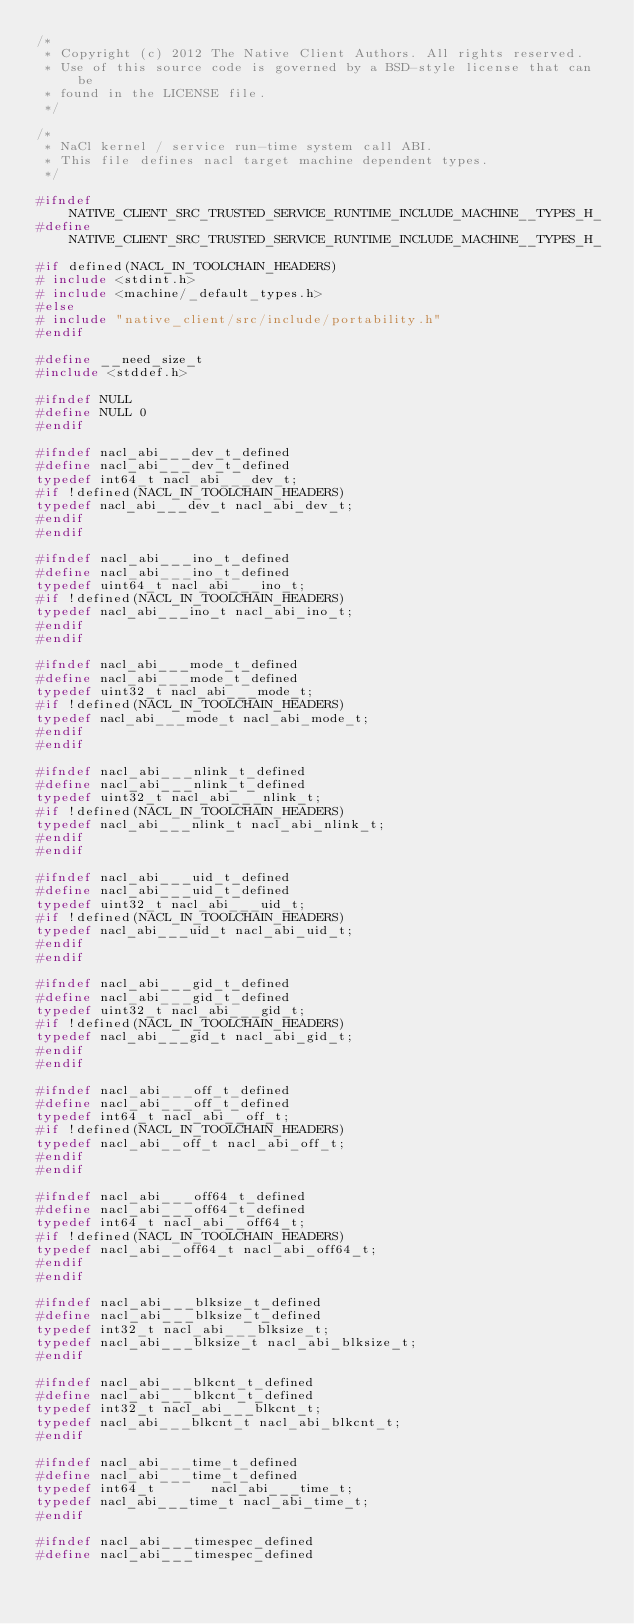Convert code to text. <code><loc_0><loc_0><loc_500><loc_500><_C_>/*
 * Copyright (c) 2012 The Native Client Authors. All rights reserved.
 * Use of this source code is governed by a BSD-style license that can be
 * found in the LICENSE file.
 */

/*
 * NaCl kernel / service run-time system call ABI.
 * This file defines nacl target machine dependent types.
 */

#ifndef NATIVE_CLIENT_SRC_TRUSTED_SERVICE_RUNTIME_INCLUDE_MACHINE__TYPES_H_
#define NATIVE_CLIENT_SRC_TRUSTED_SERVICE_RUNTIME_INCLUDE_MACHINE__TYPES_H_

#if defined(NACL_IN_TOOLCHAIN_HEADERS)
# include <stdint.h>
# include <machine/_default_types.h>
#else
# include "native_client/src/include/portability.h"
#endif

#define __need_size_t
#include <stddef.h>

#ifndef NULL
#define NULL 0
#endif

#ifndef nacl_abi___dev_t_defined
#define nacl_abi___dev_t_defined
typedef int64_t nacl_abi___dev_t;
#if !defined(NACL_IN_TOOLCHAIN_HEADERS)
typedef nacl_abi___dev_t nacl_abi_dev_t;
#endif
#endif

#ifndef nacl_abi___ino_t_defined
#define nacl_abi___ino_t_defined
typedef uint64_t nacl_abi___ino_t;
#if !defined(NACL_IN_TOOLCHAIN_HEADERS)
typedef nacl_abi___ino_t nacl_abi_ino_t;
#endif
#endif

#ifndef nacl_abi___mode_t_defined
#define nacl_abi___mode_t_defined
typedef uint32_t nacl_abi___mode_t;
#if !defined(NACL_IN_TOOLCHAIN_HEADERS)
typedef nacl_abi___mode_t nacl_abi_mode_t;
#endif
#endif

#ifndef nacl_abi___nlink_t_defined
#define nacl_abi___nlink_t_defined
typedef uint32_t nacl_abi___nlink_t;
#if !defined(NACL_IN_TOOLCHAIN_HEADERS)
typedef nacl_abi___nlink_t nacl_abi_nlink_t;
#endif
#endif

#ifndef nacl_abi___uid_t_defined
#define nacl_abi___uid_t_defined
typedef uint32_t nacl_abi___uid_t;
#if !defined(NACL_IN_TOOLCHAIN_HEADERS)
typedef nacl_abi___uid_t nacl_abi_uid_t;
#endif
#endif

#ifndef nacl_abi___gid_t_defined
#define nacl_abi___gid_t_defined
typedef uint32_t nacl_abi___gid_t;
#if !defined(NACL_IN_TOOLCHAIN_HEADERS)
typedef nacl_abi___gid_t nacl_abi_gid_t;
#endif
#endif

#ifndef nacl_abi___off_t_defined
#define nacl_abi___off_t_defined
typedef int64_t nacl_abi__off_t;
#if !defined(NACL_IN_TOOLCHAIN_HEADERS)
typedef nacl_abi__off_t nacl_abi_off_t;
#endif
#endif

#ifndef nacl_abi___off64_t_defined
#define nacl_abi___off64_t_defined
typedef int64_t nacl_abi__off64_t;
#if !defined(NACL_IN_TOOLCHAIN_HEADERS)
typedef nacl_abi__off64_t nacl_abi_off64_t;
#endif
#endif

#ifndef nacl_abi___blksize_t_defined
#define nacl_abi___blksize_t_defined
typedef int32_t nacl_abi___blksize_t;
typedef nacl_abi___blksize_t nacl_abi_blksize_t;
#endif

#ifndef nacl_abi___blkcnt_t_defined
#define nacl_abi___blkcnt_t_defined
typedef int32_t nacl_abi___blkcnt_t;
typedef nacl_abi___blkcnt_t nacl_abi_blkcnt_t;
#endif

#ifndef nacl_abi___time_t_defined
#define nacl_abi___time_t_defined
typedef int64_t       nacl_abi___time_t;
typedef nacl_abi___time_t nacl_abi_time_t;
#endif

#ifndef nacl_abi___timespec_defined
#define nacl_abi___timespec_defined</code> 